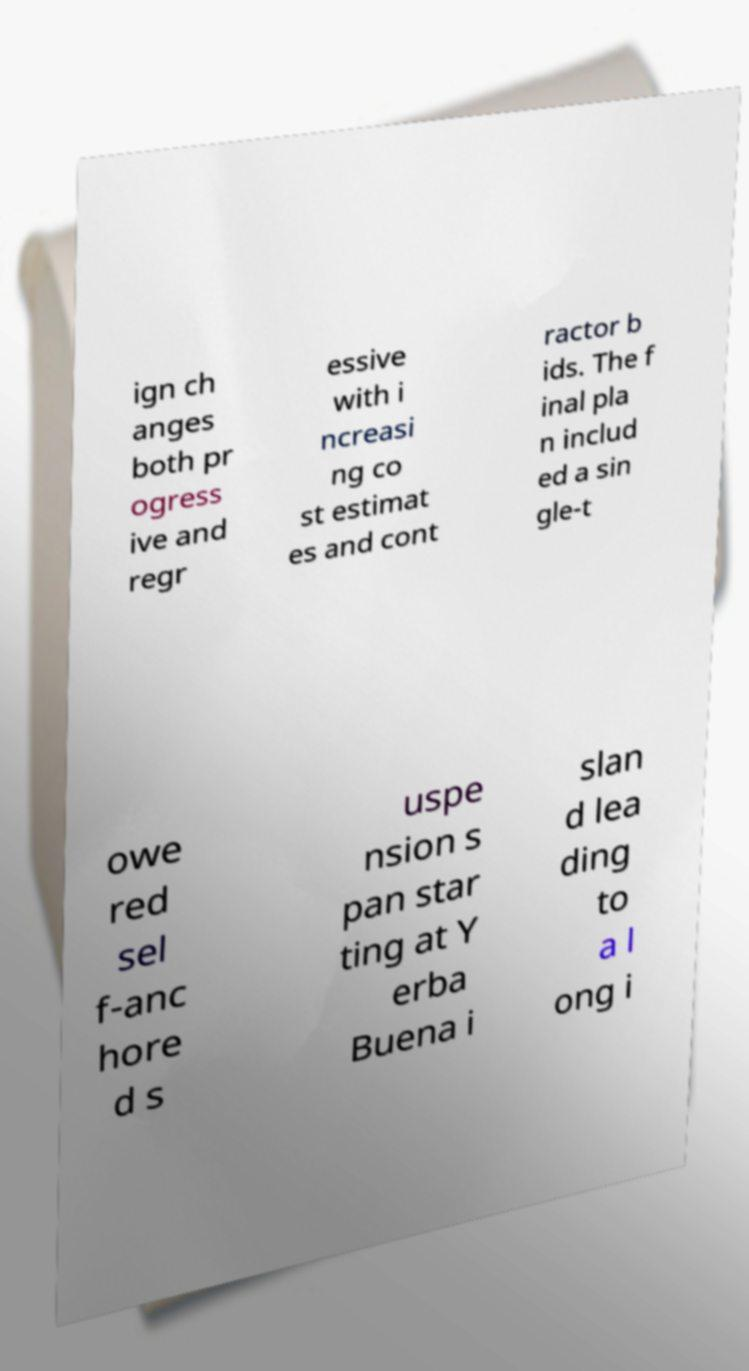Please identify and transcribe the text found in this image. ign ch anges both pr ogress ive and regr essive with i ncreasi ng co st estimat es and cont ractor b ids. The f inal pla n includ ed a sin gle-t owe red sel f-anc hore d s uspe nsion s pan star ting at Y erba Buena i slan d lea ding to a l ong i 